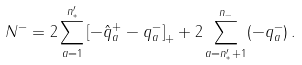<formula> <loc_0><loc_0><loc_500><loc_500>N ^ { - } = 2 \sum _ { a = 1 } ^ { n ^ { \prime } _ { * } } \left [ - \hat { q } ^ { + } _ { a } - q ^ { - } _ { a } \right ] _ { + } + 2 \sum _ { a = n ^ { \prime } _ { * } + 1 } ^ { n _ { - } } ( - q ^ { - } _ { a } ) \, .</formula> 